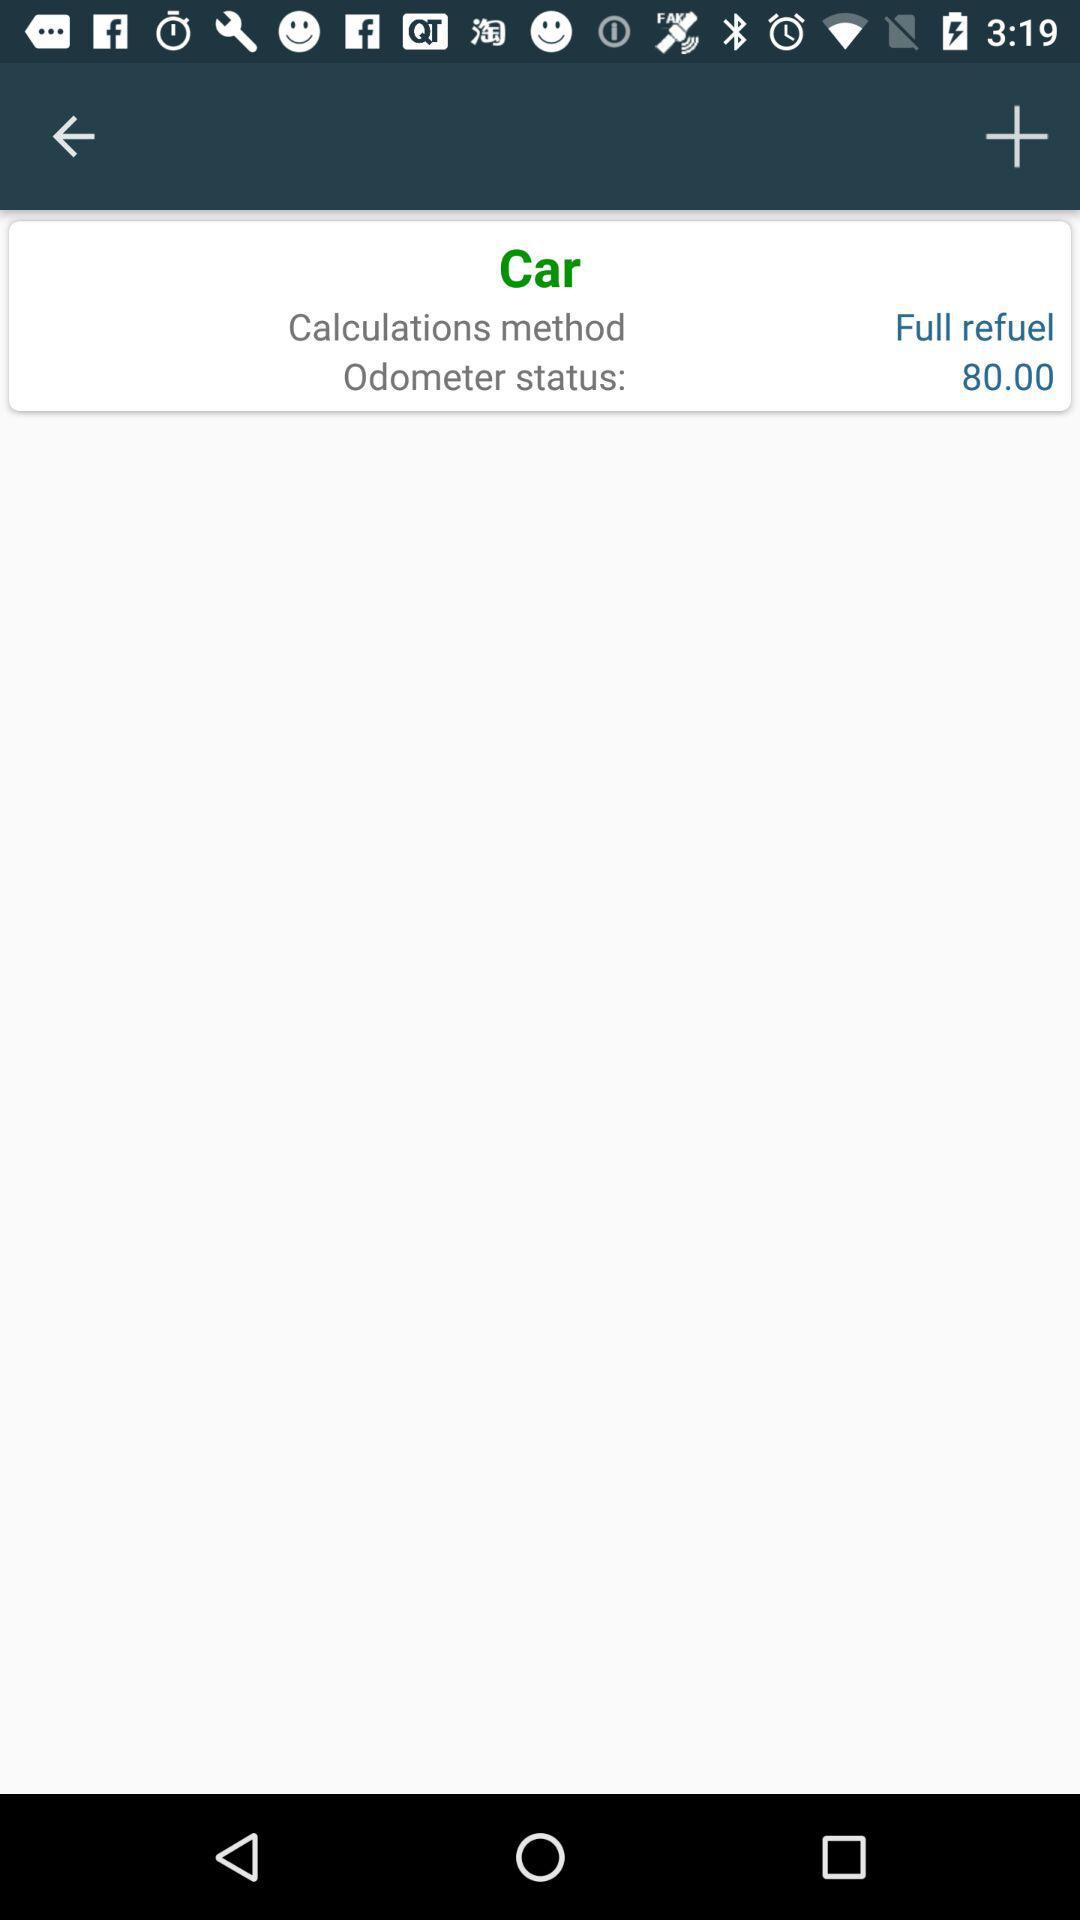What is the odometer status? The odometer status is 80. 